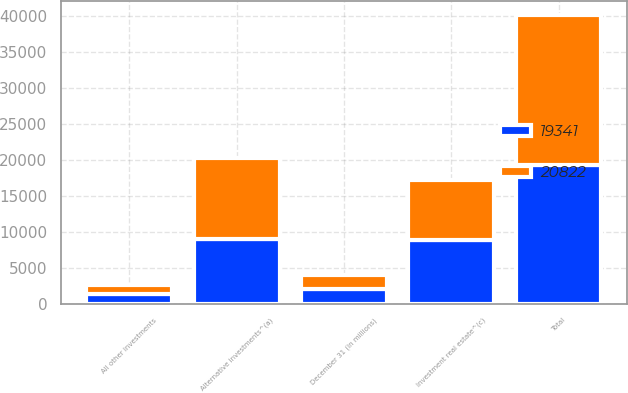Convert chart. <chart><loc_0><loc_0><loc_500><loc_500><stacked_bar_chart><ecel><fcel>December 31 (in millions)<fcel>Alternative investments^(a)<fcel>Investment real estate^(c)<fcel>All other investments<fcel>Total<nl><fcel>19341<fcel>2018<fcel>8966<fcel>8935<fcel>1440<fcel>19341<nl><fcel>20822<fcel>2017<fcel>11308<fcel>8258<fcel>1256<fcel>20822<nl></chart> 